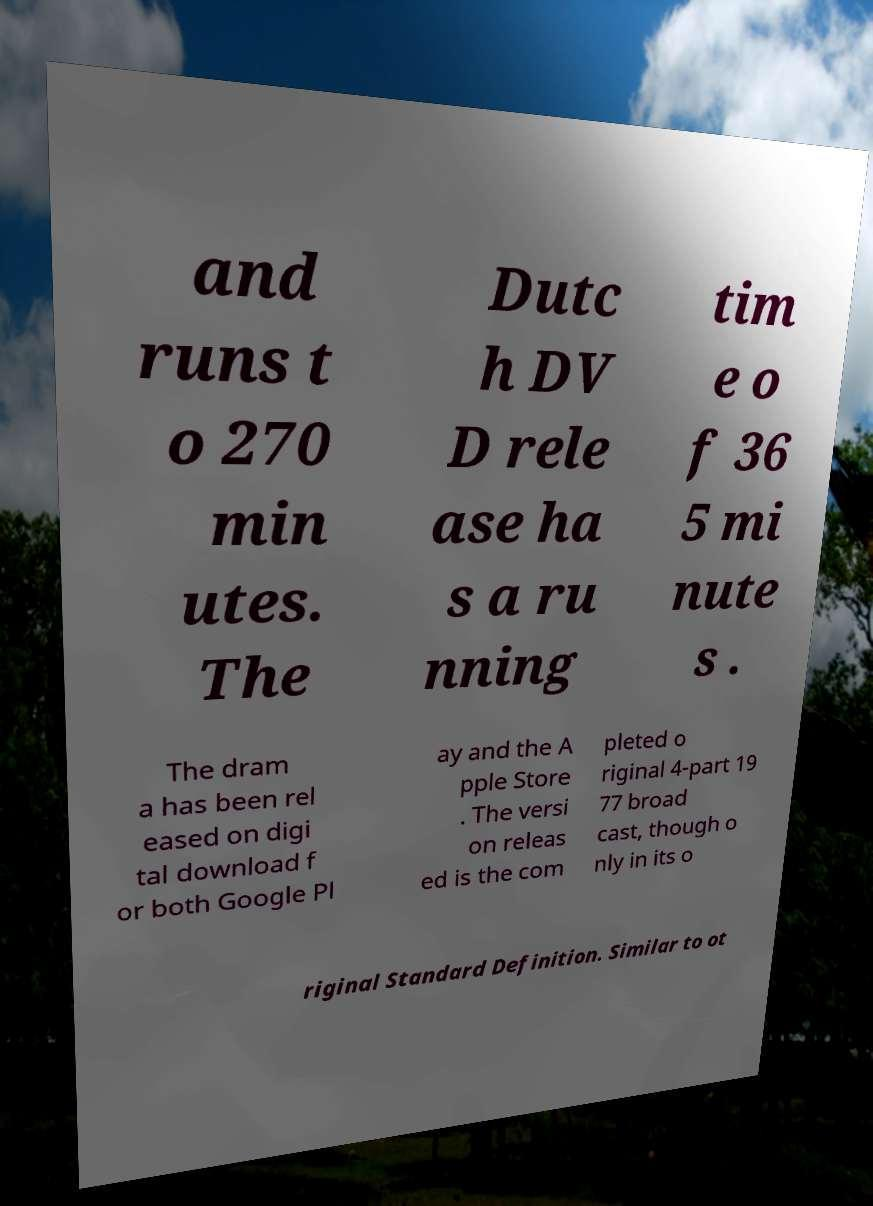For documentation purposes, I need the text within this image transcribed. Could you provide that? and runs t o 270 min utes. The Dutc h DV D rele ase ha s a ru nning tim e o f 36 5 mi nute s . The dram a has been rel eased on digi tal download f or both Google Pl ay and the A pple Store . The versi on releas ed is the com pleted o riginal 4-part 19 77 broad cast, though o nly in its o riginal Standard Definition. Similar to ot 